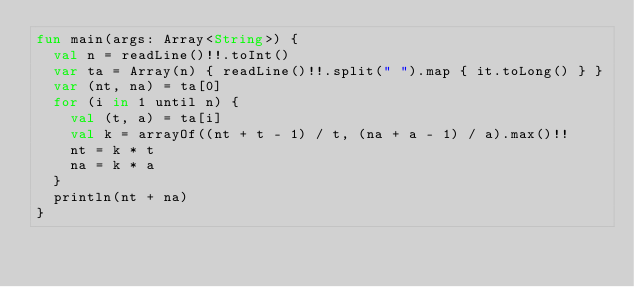<code> <loc_0><loc_0><loc_500><loc_500><_Kotlin_>fun main(args: Array<String>) {
  val n = readLine()!!.toInt()
  var ta = Array(n) { readLine()!!.split(" ").map { it.toLong() } }
  var (nt, na) = ta[0]
  for (i in 1 until n) {
    val (t, a) = ta[i]
    val k = arrayOf((nt + t - 1) / t, (na + a - 1) / a).max()!!
    nt = k * t
    na = k * a
  }
  println(nt + na)
}
</code> 